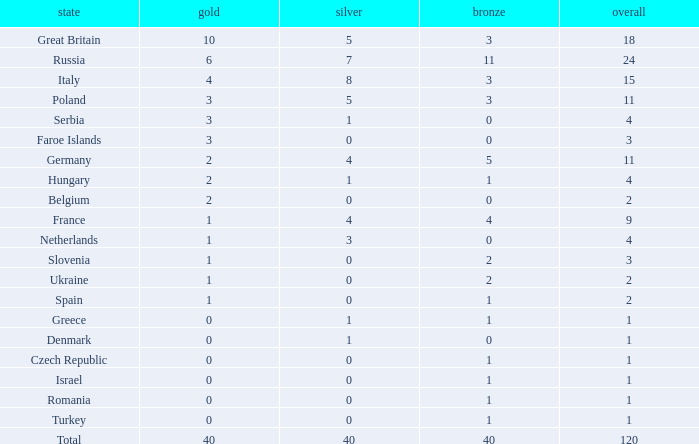What is Turkey's average Gold entry that also has a Bronze entry that is smaller than 2 and the Total is greater than 1? None. Help me parse the entirety of this table. {'header': ['state', 'gold', 'silver', 'bronze', 'overall'], 'rows': [['Great Britain', '10', '5', '3', '18'], ['Russia', '6', '7', '11', '24'], ['Italy', '4', '8', '3', '15'], ['Poland', '3', '5', '3', '11'], ['Serbia', '3', '1', '0', '4'], ['Faroe Islands', '3', '0', '0', '3'], ['Germany', '2', '4', '5', '11'], ['Hungary', '2', '1', '1', '4'], ['Belgium', '2', '0', '0', '2'], ['France', '1', '4', '4', '9'], ['Netherlands', '1', '3', '0', '4'], ['Slovenia', '1', '0', '2', '3'], ['Ukraine', '1', '0', '2', '2'], ['Spain', '1', '0', '1', '2'], ['Greece', '0', '1', '1', '1'], ['Denmark', '0', '1', '0', '1'], ['Czech Republic', '0', '0', '1', '1'], ['Israel', '0', '0', '1', '1'], ['Romania', '0', '0', '1', '1'], ['Turkey', '0', '0', '1', '1'], ['Total', '40', '40', '40', '120']]} 